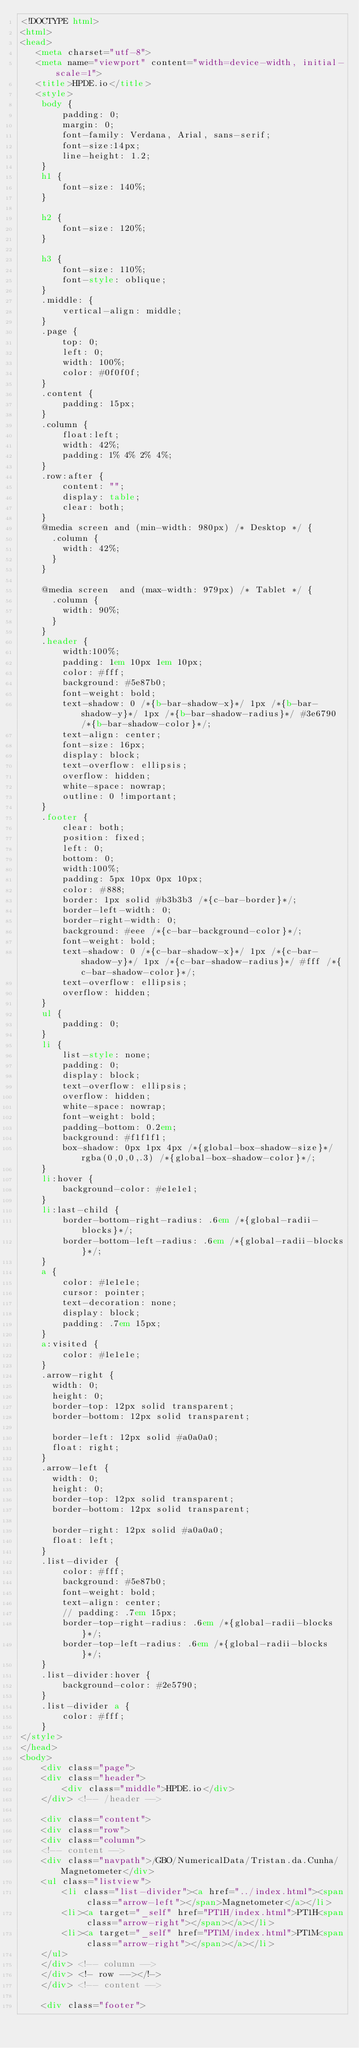Convert code to text. <code><loc_0><loc_0><loc_500><loc_500><_HTML_><!DOCTYPE html>
<html>
<head>
   <meta charset="utf-8">
   <meta name="viewport" content="width=device-width, initial-scale=1">
   <title>HPDE.io</title>
   <style>
	body {
		padding: 0;
		margin: 0;
		font-family: Verdana, Arial, sans-serif; 
		font-size:14px; 
		line-height: 1.2;
	}
	h1 {
		font-size: 140%;
	}

	h2 {
		font-size: 120%;
	}

	h3 {
		font-size: 110%;
		font-style: oblique;
	}
	.middle: {
		vertical-align: middle;
	}
	.page {
		top: 0;
		left: 0;
		width: 100%;
		color: #0f0f0f;
	}
	.content {
		padding: 15px;
	}
	.column {
		float:left;
		width: 42%;
		padding: 1% 4% 2% 4%;
	}
	.row:after {
		content: "";
		display: table;
		clear: both;
	}	
	@media screen and (min-width: 980px) /* Desktop */ {
	  .column {
		width: 42%;
	  }
	}

	@media screen  and (max-width: 979px) /* Tablet */ {
	  .column {
		width: 90%;
	  }
	}
	.header {
		width:100%;
		padding: 1em 10px 1em 10px;
		color: #fff;
		background: #5e87b0;
		font-weight: bold;
		text-shadow: 0 /*{b-bar-shadow-x}*/ 1px /*{b-bar-shadow-y}*/ 1px /*{b-bar-shadow-radius}*/ #3e6790 /*{b-bar-shadow-color}*/;
		text-align: center;
		font-size: 16px;
		display: block;
		text-overflow: ellipsis;
		overflow: hidden;
		white-space: nowrap;
		outline: 0 !important;
	}
	.footer {
		clear: both;
		position: fixed;
		left: 0;
		bottom: 0;
		width:100%;
		padding: 5px 10px 0px 10px;
		color: #888;
		border: 1px solid #b3b3b3 /*{c-bar-border}*/;
		border-left-width: 0;
		border-right-width: 0;
		background: #eee /*{c-bar-background-color}*/;
		font-weight: bold;
		text-shadow: 0 /*{c-bar-shadow-x}*/ 1px /*{c-bar-shadow-y}*/ 1px /*{c-bar-shadow-radius}*/ #fff /*{c-bar-shadow-color}*/;
		text-overflow: ellipsis;
		overflow: hidden;
	}
	ul {
		padding: 0;
	}
	li {
		list-style: none;
		padding: 0;
		display: block;
	    text-overflow: ellipsis;
		overflow: hidden;
		white-space: nowrap;
		font-weight: bold;
		padding-bottom: 0.2em;
		background: #f1f1f1;
		box-shadow: 0px 1px 4px /*{global-box-shadow-size}*/ rgba(0,0,0,.3) /*{global-box-shadow-color}*/;
	}
	li:hover {
		background-color: #e1e1e1;
	}
	li:last-child {
		border-bottom-right-radius: .6em /*{global-radii-blocks}*/;
		border-bottom-left-radius: .6em /*{global-radii-blocks}*/;
	}
	a {
		color: #1e1e1e;
		cursor: pointer;
		text-decoration: none;
		display: block;
		padding: .7em 15px;
	}
	a:visited {
		color: #1e1e1e;
	}
	.arrow-right {
	  width: 0; 
	  height: 0; 
	  border-top: 12px solid transparent;
	  border-bottom: 12px solid transparent;
	  
	  border-left: 12px solid #a0a0a0;
	  float: right;
	}
	.arrow-left {
	  width: 0; 
	  height: 0; 
	  border-top: 12px solid transparent;
	  border-bottom: 12px solid transparent;
	  
	  border-right: 12px solid #a0a0a0;
	  float: left;
	}
	.list-divider {
		color: #fff;
		background: #5e87b0;
		font-weight: bold;
		text-align: center;
		// padding: .7em 15px;
		border-top-right-radius: .6em /*{global-radii-blocks}*/;
		border-top-left-radius: .6em /*{global-radii-blocks}*/;
	}
	.list-divider:hover {
		background-color: #2e5790;
	}
	.list-divider a {
		color: #fff;
	}
</style>
</head>
<body>
	<div class="page">
	<div class="header">
		<div class="middle">HPDE.io</div>
	</div> <!-- /header -->
	
	<div class="content">
	<div class="row">
	<div class="column">
	<!-- content -->
	<div class="navpath">/GBO/NumericalData/Tristan.da.Cunha/Magnetometer</div>
	<ul class="listview">
		<li class="list-divider"><a href="../index.html"><span class="arrow-left"></span>Magnetometer</a></li>
		<li><a target="_self" href="PT1H/index.html">PT1H<span class="arrow-right"></span></a></li>
		<li><a target="_self" href="PT1M/index.html">PT1M<span class="arrow-right"></span></a></li>
	</ul>
	</div> <!-- column -->
	</div> <!- row --></!->
	</div> <!-- content -->
	
	<div class="footer"></code> 